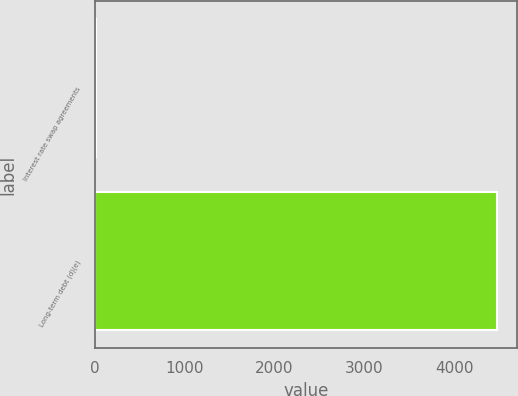Convert chart. <chart><loc_0><loc_0><loc_500><loc_500><bar_chart><fcel>Interest rate swap agreements<fcel>Long-term debt (d)(e)<nl><fcel>10<fcel>4480<nl></chart> 